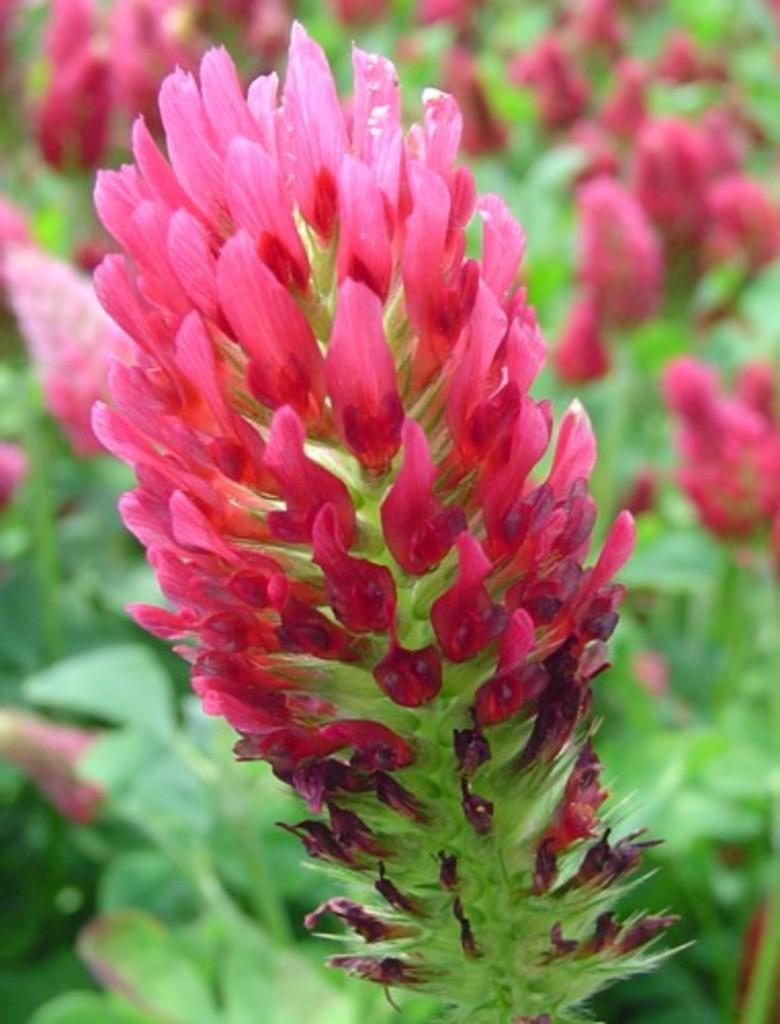What types of living organisms can be seen in the image? There are many plants in the image. What specific features can be observed on the plants? There are flowers on the plants. What type of guitar is being played by the dogs in the image? There are no dogs or guitars present in the image; it features many plants with flowers. 